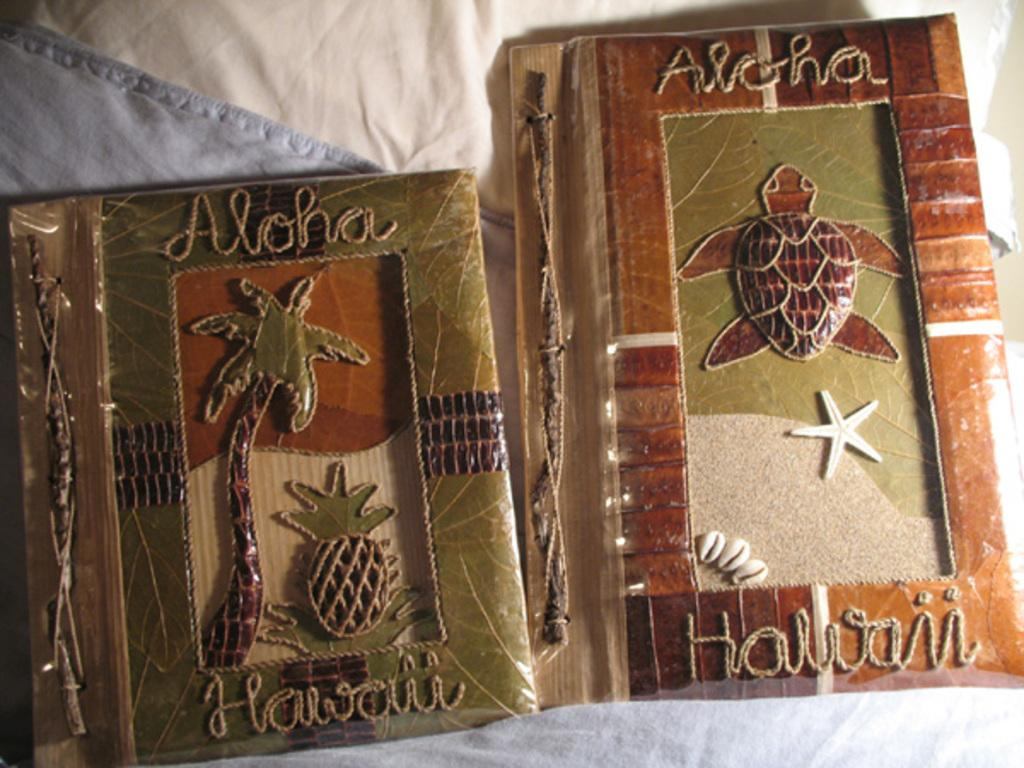<image>
Describe the image concisely. Two tropical looking decorations that say Aloha Hawaii. 